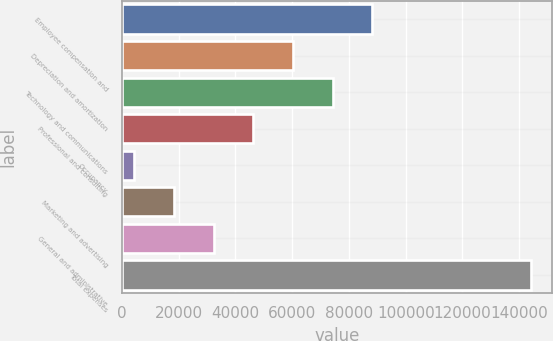Convert chart. <chart><loc_0><loc_0><loc_500><loc_500><bar_chart><fcel>Employee compensation and<fcel>Depreciation and amortization<fcel>Technology and communications<fcel>Professional and consulting<fcel>Occupancy<fcel>Marketing and advertising<fcel>General and administrative<fcel>Total expenses<nl><fcel>88295.2<fcel>60323.8<fcel>74309.5<fcel>46338.1<fcel>4381<fcel>18366.7<fcel>32352.4<fcel>144238<nl></chart> 